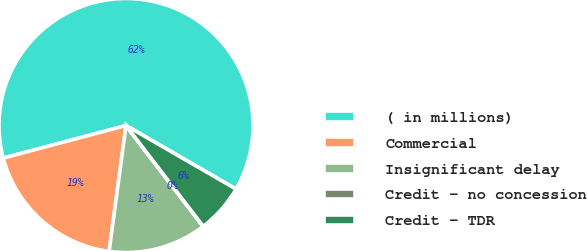Convert chart to OTSL. <chart><loc_0><loc_0><loc_500><loc_500><pie_chart><fcel>( in millions)<fcel>Commercial<fcel>Insignificant delay<fcel>Credit - no concession<fcel>Credit - TDR<nl><fcel>62.46%<fcel>18.75%<fcel>12.51%<fcel>0.02%<fcel>6.26%<nl></chart> 